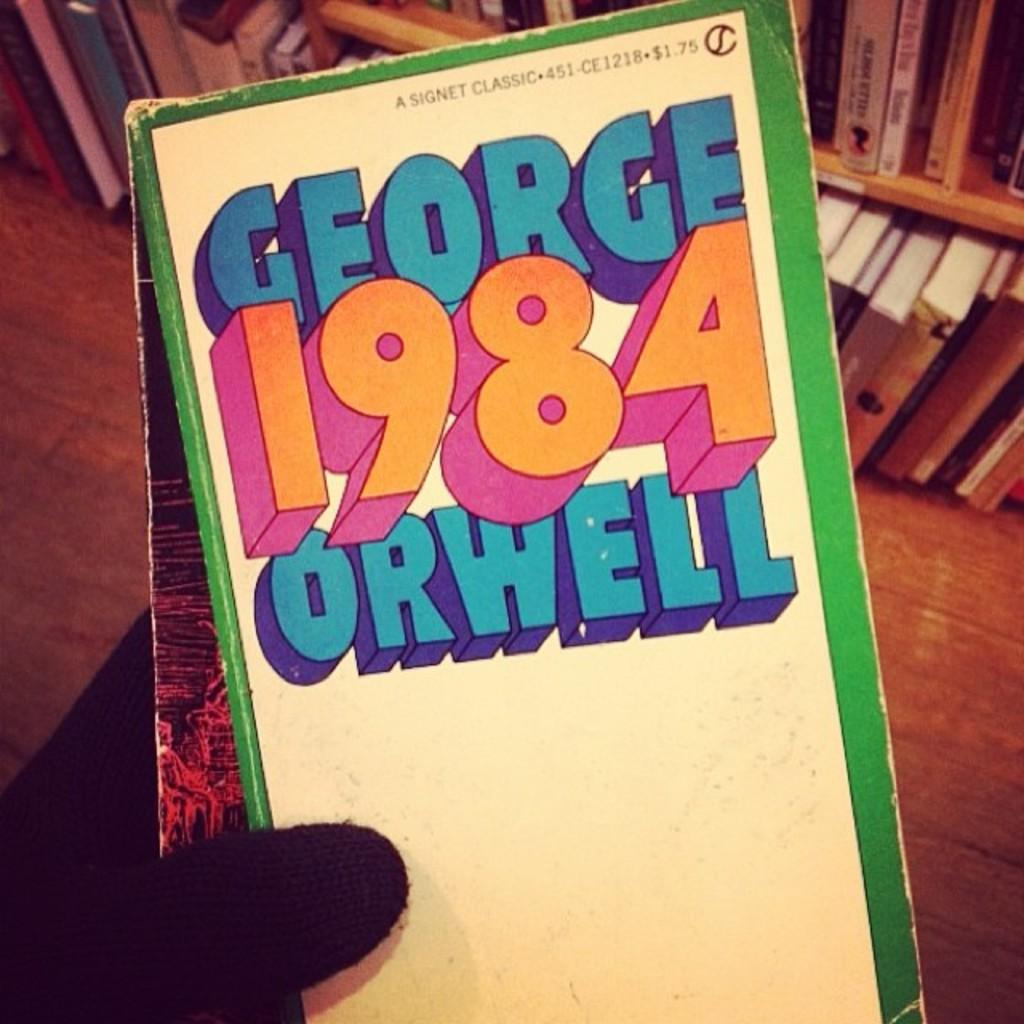<image>
Describe the image concisely. Top edge of book magnified with 84 Orwell on cover. 